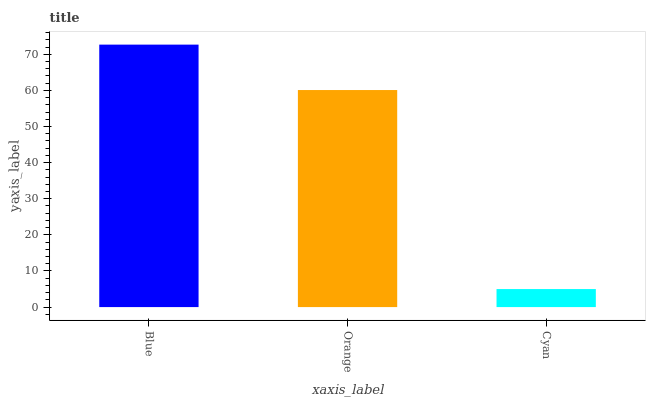Is Cyan the minimum?
Answer yes or no. Yes. Is Blue the maximum?
Answer yes or no. Yes. Is Orange the minimum?
Answer yes or no. No. Is Orange the maximum?
Answer yes or no. No. Is Blue greater than Orange?
Answer yes or no. Yes. Is Orange less than Blue?
Answer yes or no. Yes. Is Orange greater than Blue?
Answer yes or no. No. Is Blue less than Orange?
Answer yes or no. No. Is Orange the high median?
Answer yes or no. Yes. Is Orange the low median?
Answer yes or no. Yes. Is Blue the high median?
Answer yes or no. No. Is Cyan the low median?
Answer yes or no. No. 